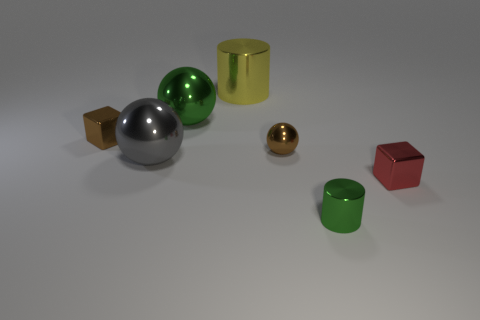Subtract all green shiny spheres. How many spheres are left? 2 Add 2 large purple rubber things. How many objects exist? 9 Subtract all red blocks. How many blocks are left? 1 Subtract 0 cyan blocks. How many objects are left? 7 Subtract all spheres. How many objects are left? 4 Subtract 2 spheres. How many spheres are left? 1 Subtract all green cubes. Subtract all blue spheres. How many cubes are left? 2 Subtract all gray blocks. How many red cylinders are left? 0 Subtract all small red cubes. Subtract all shiny cylinders. How many objects are left? 4 Add 6 gray metallic balls. How many gray metallic balls are left? 7 